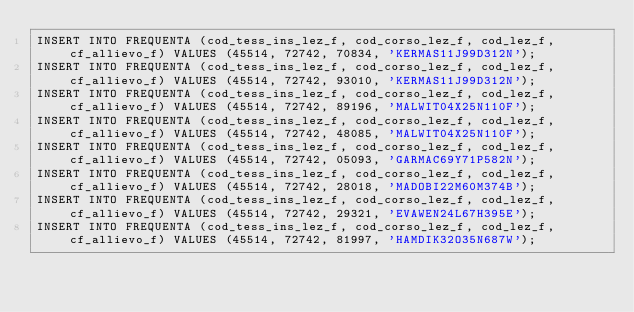Convert code to text. <code><loc_0><loc_0><loc_500><loc_500><_SQL_>INSERT INTO FREQUENTA (cod_tess_ins_lez_f, cod_corso_lez_f, cod_lez_f, cf_allievo_f) VALUES (45514, 72742, 70834, 'KERMAS11J99D312N');
INSERT INTO FREQUENTA (cod_tess_ins_lez_f, cod_corso_lez_f, cod_lez_f, cf_allievo_f) VALUES (45514, 72742, 93010, 'KERMAS11J99D312N');
INSERT INTO FREQUENTA (cod_tess_ins_lez_f, cod_corso_lez_f, cod_lez_f, cf_allievo_f) VALUES (45514, 72742, 89196, 'MALWIT04X25N110F');
INSERT INTO FREQUENTA (cod_tess_ins_lez_f, cod_corso_lez_f, cod_lez_f, cf_allievo_f) VALUES (45514, 72742, 48085, 'MALWIT04X25N110F');
INSERT INTO FREQUENTA (cod_tess_ins_lez_f, cod_corso_lez_f, cod_lez_f, cf_allievo_f) VALUES (45514, 72742, 05093, 'GARMAC69Y71P582N');
INSERT INTO FREQUENTA (cod_tess_ins_lez_f, cod_corso_lez_f, cod_lez_f, cf_allievo_f) VALUES (45514, 72742, 28018, 'MADOBI22M60M374B');
INSERT INTO FREQUENTA (cod_tess_ins_lez_f, cod_corso_lez_f, cod_lez_f, cf_allievo_f) VALUES (45514, 72742, 29321, 'EVAWEN24L67H395E');
INSERT INTO FREQUENTA (cod_tess_ins_lez_f, cod_corso_lez_f, cod_lez_f, cf_allievo_f) VALUES (45514, 72742, 81997, 'HAMDIK32O35N687W');</code> 